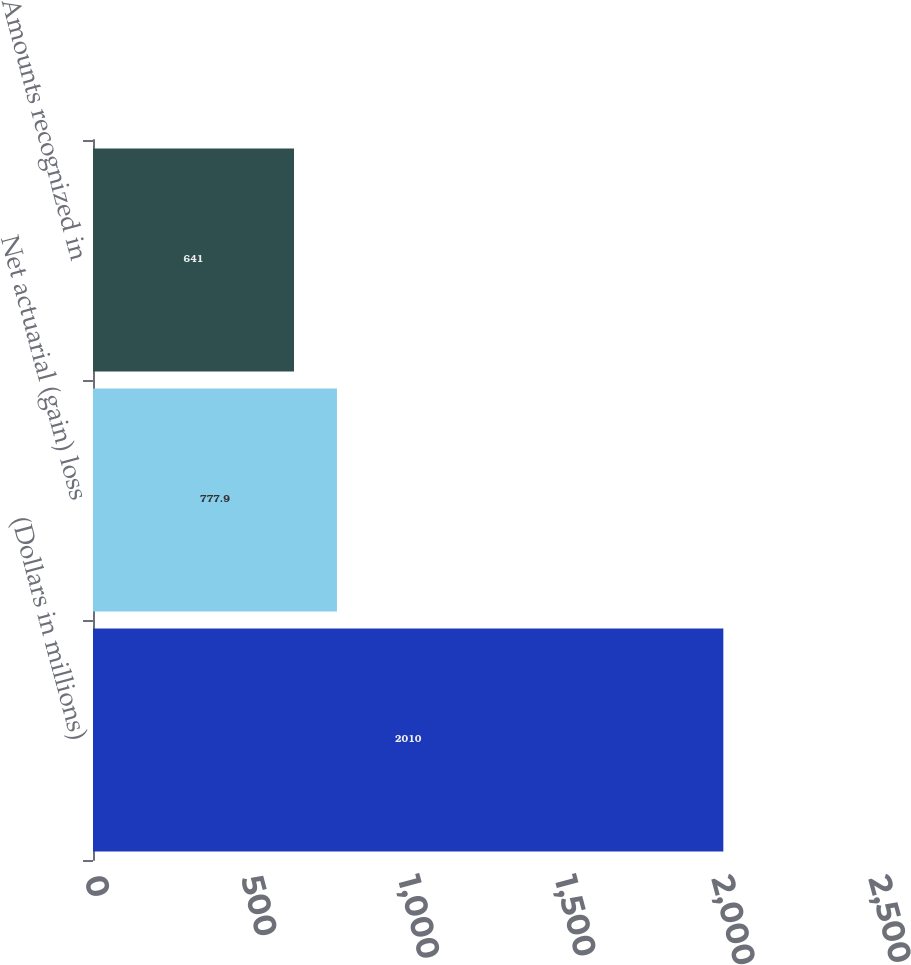Convert chart to OTSL. <chart><loc_0><loc_0><loc_500><loc_500><bar_chart><fcel>(Dollars in millions)<fcel>Net actuarial (gain) loss<fcel>Amounts recognized in<nl><fcel>2010<fcel>777.9<fcel>641<nl></chart> 